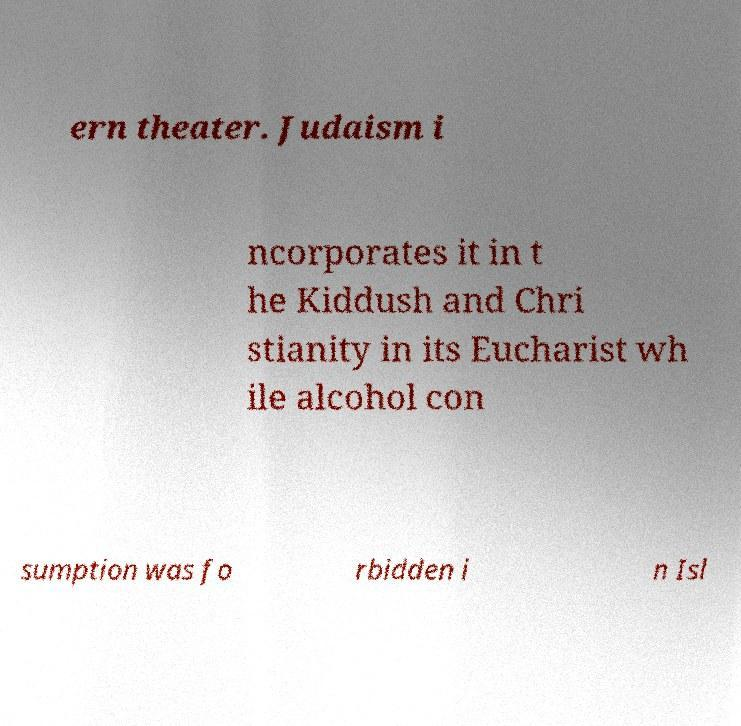Please identify and transcribe the text found in this image. ern theater. Judaism i ncorporates it in t he Kiddush and Chri stianity in its Eucharist wh ile alcohol con sumption was fo rbidden i n Isl 